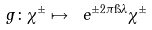<formula> <loc_0><loc_0><loc_500><loc_500>g \colon \chi ^ { \pm } \mapsto \ e ^ { \pm 2 \pi \i \lambda } \chi ^ { \pm }</formula> 